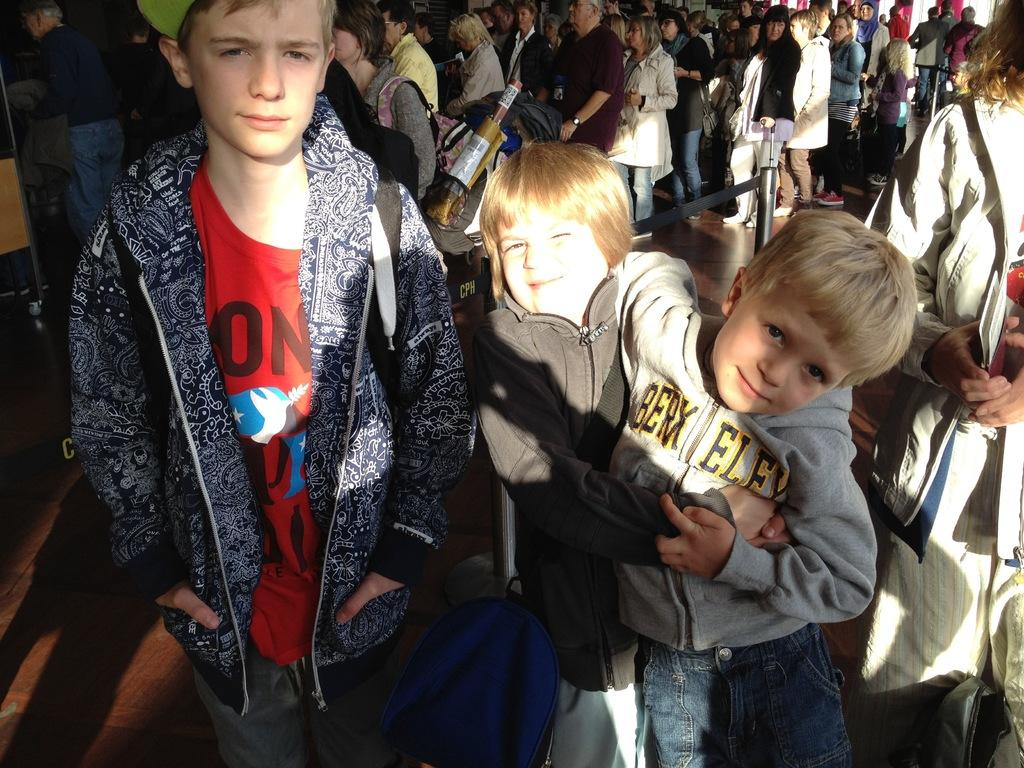What is the main subject of the image? The main subject of the image is a crowd. Can you describe the crowd in the image? Unfortunately, the provided facts do not give any details about the crowd, such as their size, location, or activities. What type of ship can be seen sailing in the moonlight in the image? There is no ship or moon present in the image; it only features a crowd. 